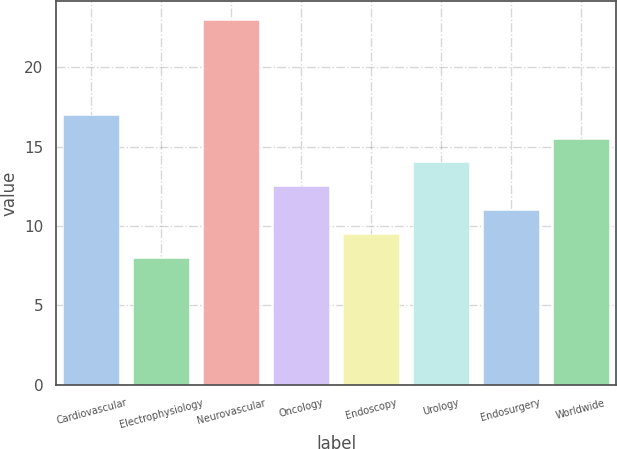Convert chart to OTSL. <chart><loc_0><loc_0><loc_500><loc_500><bar_chart><fcel>Cardiovascular<fcel>Electrophysiology<fcel>Neurovascular<fcel>Oncology<fcel>Endoscopy<fcel>Urology<fcel>Endosurgery<fcel>Worldwide<nl><fcel>17<fcel>8<fcel>23<fcel>12.5<fcel>9.5<fcel>14<fcel>11<fcel>15.5<nl></chart> 